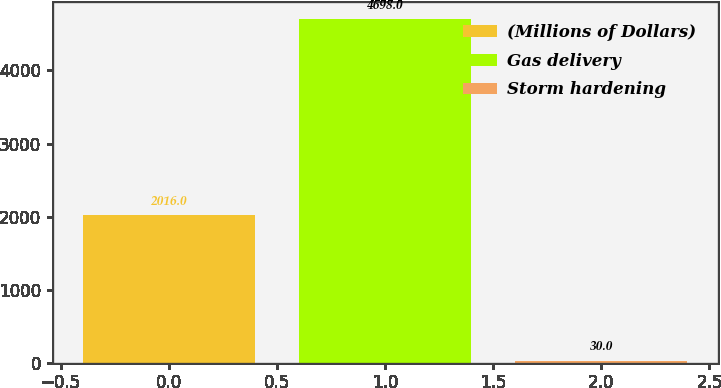Convert chart. <chart><loc_0><loc_0><loc_500><loc_500><bar_chart><fcel>(Millions of Dollars)<fcel>Gas delivery<fcel>Storm hardening<nl><fcel>2016<fcel>4698<fcel>30<nl></chart> 